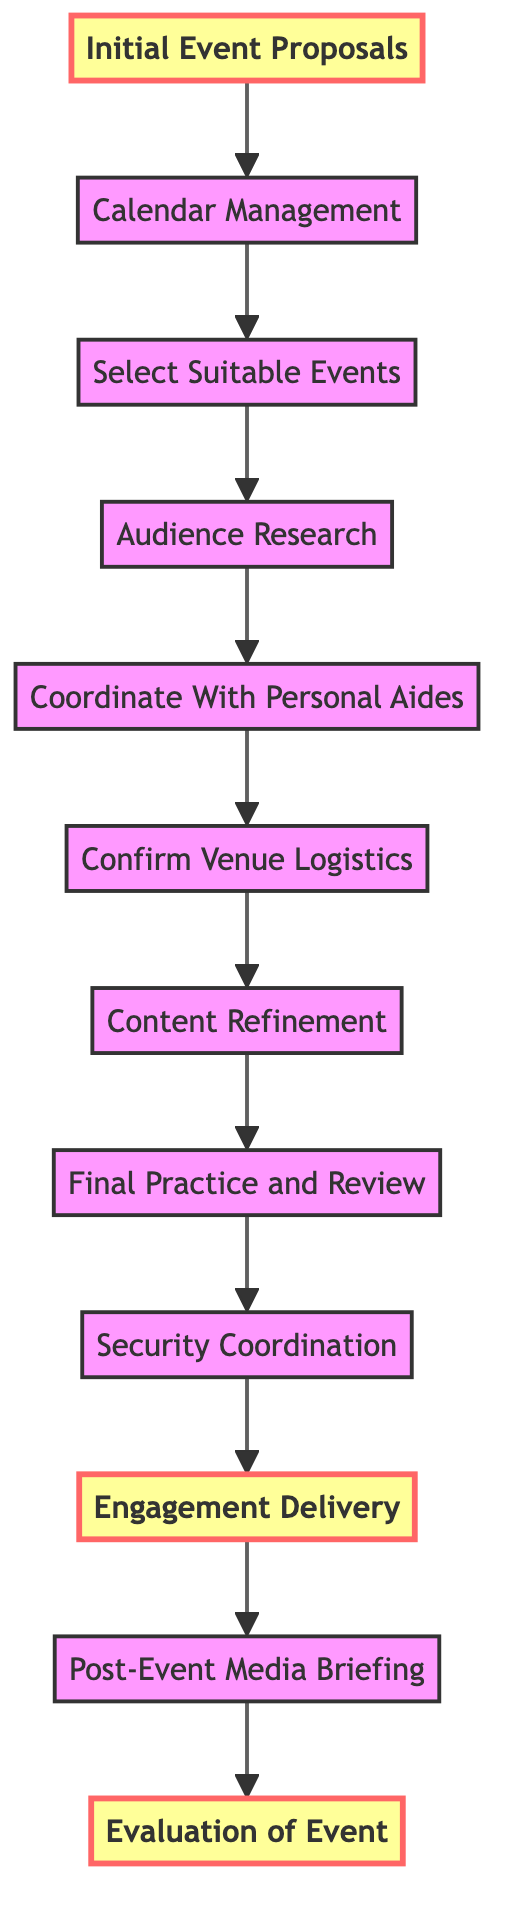What is the first step in the process? The first step is "Initial Event Proposals," which is at the bottom of the flowchart as the starting point for scheduling public speaking engagements.
Answer: Initial Event Proposals What is the last step in the process? The last step is "Evaluation of Event," located at the top of the flowchart, which summarizes the engagement's success and areas for improvement.
Answer: Evaluation of Event How many total steps are there in the flowchart? By counting each individual stage from "Initial Event Proposals" to "Evaluation of Event," there are 12 distinct steps represented in the flowchart.
Answer: 12 What step comes immediately before "Engagement Delivery"? "Security Coordination" is the step that directly precedes "Engagement Delivery," ensuring that safety and media interactions are managed prior to the speech.
Answer: Security Coordination Which step is focused on the media after the event? "Post-Event Media Briefing" specifically addresses the media following the event to manage public relations and mitigate scrutiny.
Answer: Post-Event Media Briefing What two steps are highlighted in the diagram? The steps highlighted in the diagram are "Initial Event Proposals" and "Engagement Delivery," indicating their importance in the overall process.
Answer: Initial Event Proposals, Engagement Delivery What is the relationship between "Content Refinement" and "Final Practice and Review"? "Content Refinement" occurs before "Final Practice and Review," indicating that content needs to be refined before the speech is rehearsed with the team.
Answer: "Content Refinement" precedes "Final Practice and Review" How does "Audience Research" influence the flow of scheduling? "Audience Research" is conducted after selecting suitable events and ensures that the speech content is tailored to the audience's demographics and interests, enhancing engagement effectiveness.
Answer: It guides speech content tailoring How many steps lead to "Engagement Delivery"? There are five steps leading to "Engagement Delivery," which includes "Final Practice and Review," "Security Coordination," among others, creating a pathway to the delivery of the speech.
Answer: 5 